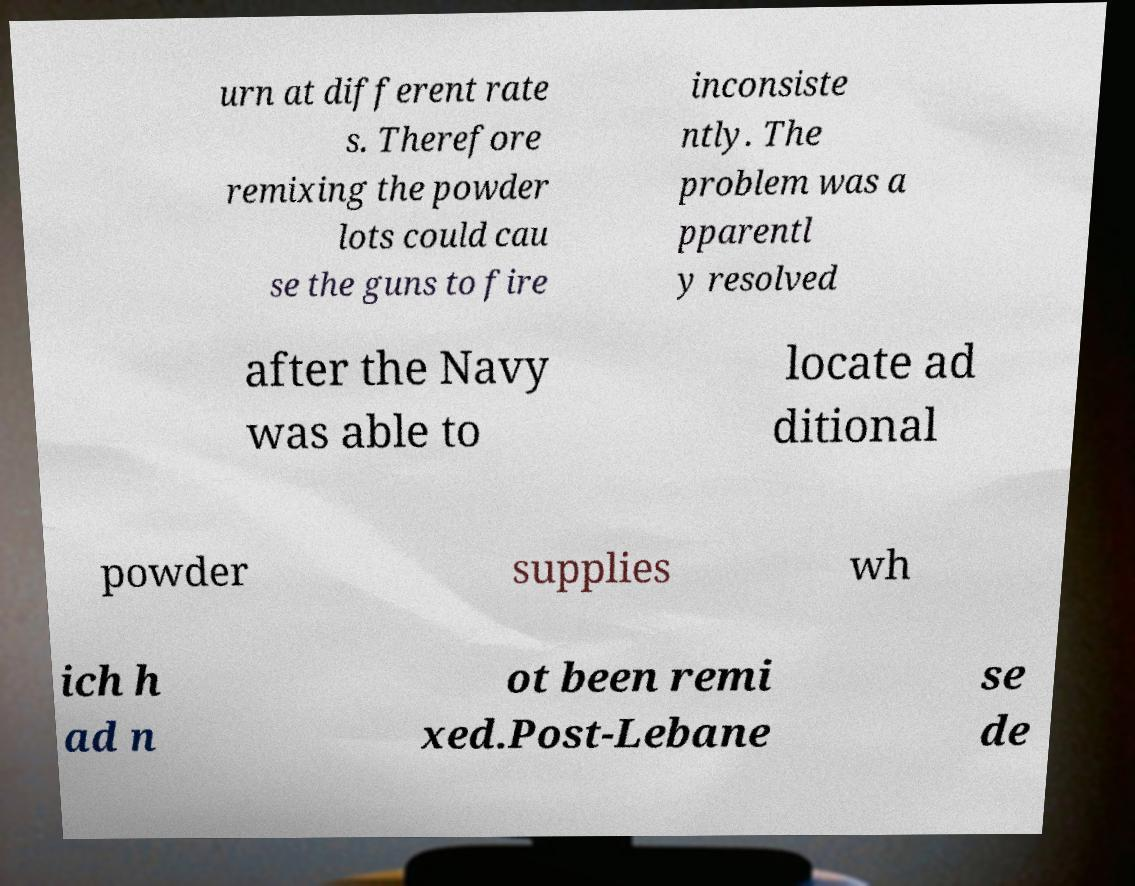Could you assist in decoding the text presented in this image and type it out clearly? urn at different rate s. Therefore remixing the powder lots could cau se the guns to fire inconsiste ntly. The problem was a pparentl y resolved after the Navy was able to locate ad ditional powder supplies wh ich h ad n ot been remi xed.Post-Lebane se de 